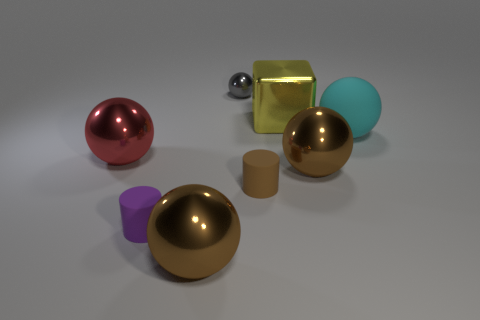What is the size of the matte thing in front of the small matte object that is to the right of the small gray thing?
Your answer should be very brief. Small. What shape is the matte object that is to the right of the large brown metal thing that is to the right of the ball that is behind the large yellow metal block?
Give a very brief answer. Sphere. There is a large block that is the same material as the large red thing; what color is it?
Offer a very short reply. Yellow. What is the color of the large metallic object behind the matte object that is behind the red metallic object that is behind the tiny brown rubber cylinder?
Provide a short and direct response. Yellow. How many cylinders are brown metallic objects or tiny gray metallic objects?
Keep it short and to the point. 0. The large shiny block is what color?
Make the answer very short. Yellow. How many things are either green metallic cubes or large cyan objects?
Your response must be concise. 1. There is a red sphere that is the same size as the yellow shiny object; what is its material?
Offer a very short reply. Metal. There is a matte object that is behind the large red shiny ball; how big is it?
Provide a succinct answer. Large. What is the material of the small brown cylinder?
Your response must be concise. Rubber. 